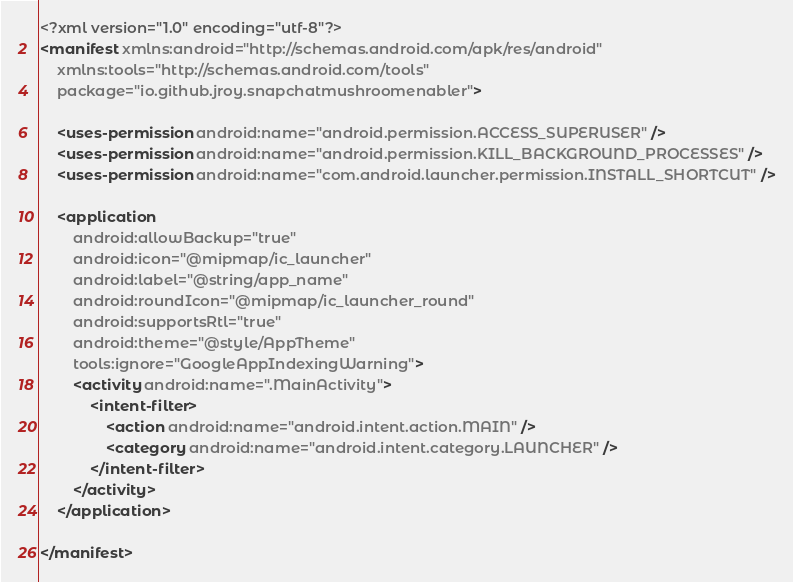Convert code to text. <code><loc_0><loc_0><loc_500><loc_500><_XML_><?xml version="1.0" encoding="utf-8"?>
<manifest xmlns:android="http://schemas.android.com/apk/res/android"
    xmlns:tools="http://schemas.android.com/tools"
    package="io.github.jroy.snapchatmushroomenabler">

    <uses-permission android:name="android.permission.ACCESS_SUPERUSER" />
    <uses-permission android:name="android.permission.KILL_BACKGROUND_PROCESSES" />
    <uses-permission android:name="com.android.launcher.permission.INSTALL_SHORTCUT" />

    <application
        android:allowBackup="true"
        android:icon="@mipmap/ic_launcher"
        android:label="@string/app_name"
        android:roundIcon="@mipmap/ic_launcher_round"
        android:supportsRtl="true"
        android:theme="@style/AppTheme"
        tools:ignore="GoogleAppIndexingWarning">
        <activity android:name=".MainActivity">
            <intent-filter>
                <action android:name="android.intent.action.MAIN" />
                <category android:name="android.intent.category.LAUNCHER" />
            </intent-filter>
        </activity>
    </application>

</manifest></code> 